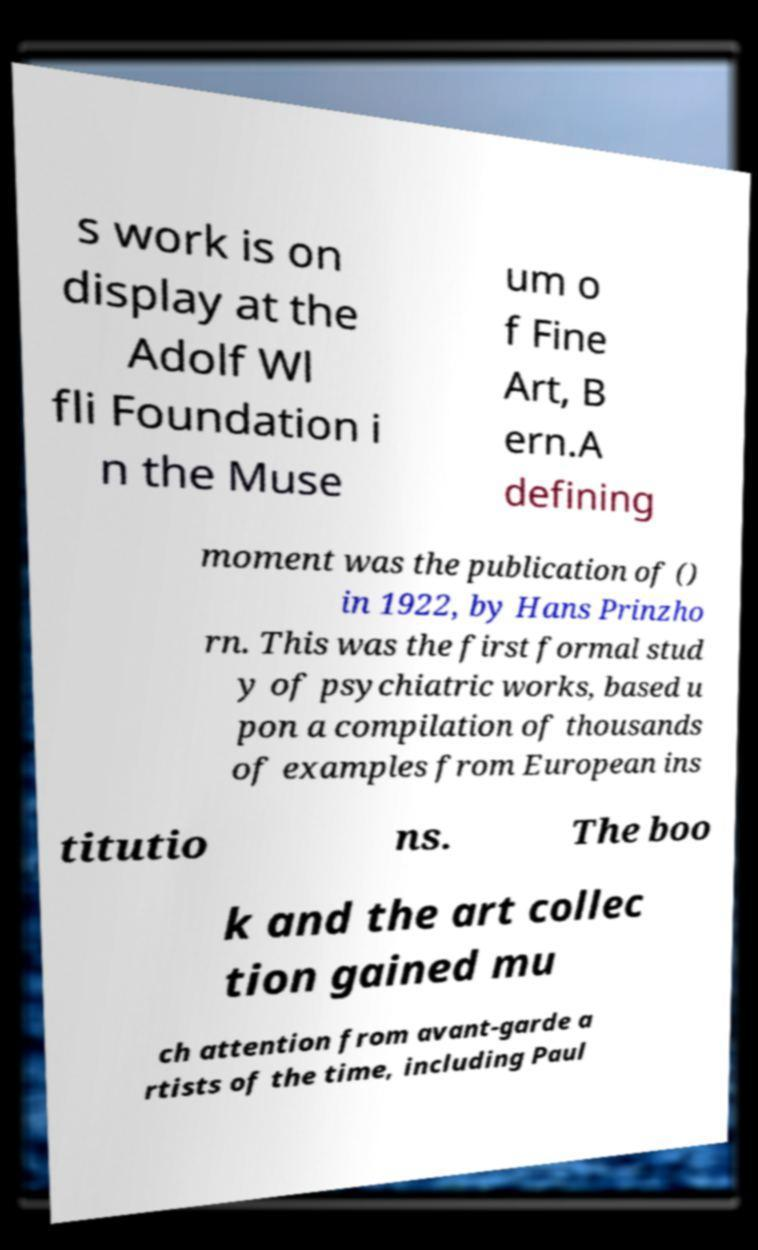Please identify and transcribe the text found in this image. s work is on display at the Adolf Wl fli Foundation i n the Muse um o f Fine Art, B ern.A defining moment was the publication of () in 1922, by Hans Prinzho rn. This was the first formal stud y of psychiatric works, based u pon a compilation of thousands of examples from European ins titutio ns. The boo k and the art collec tion gained mu ch attention from avant-garde a rtists of the time, including Paul 